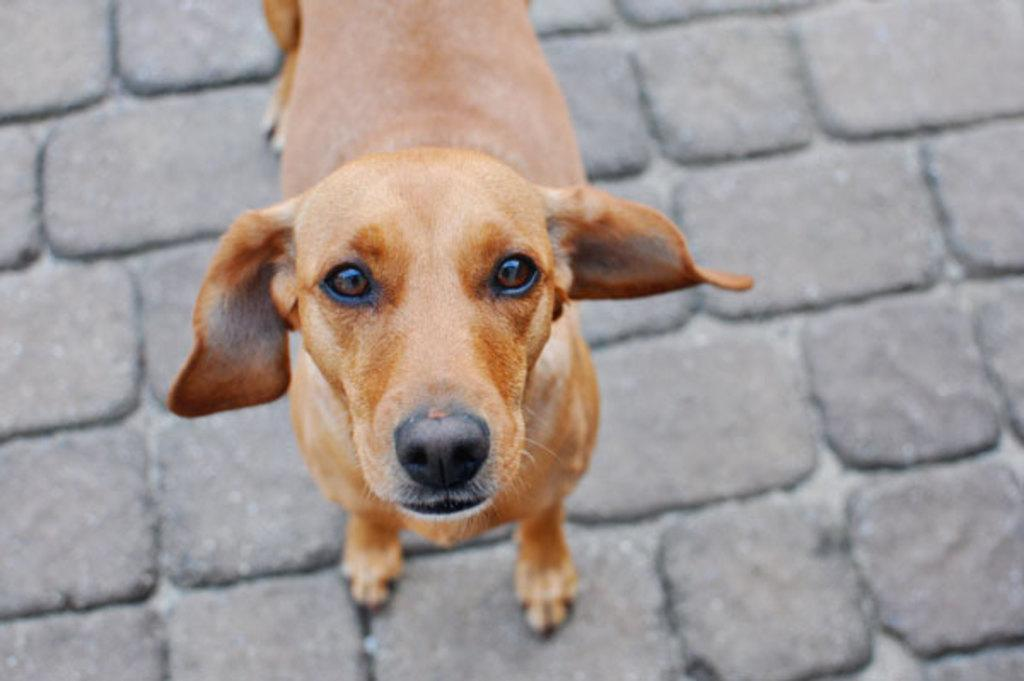What animal is present in the image? There is a dog in the image. Where is the dog positioned in the image? The dog is in the front position. How many legs of the dog are visible in the image? The dog has two legs visible in the image. What surface is the dog on in the image? The dog is on the ground. What type of laborer is working in the background of the image? There is no laborer present in the image; it only features a dog. What dish is being served for dinner in the image? There is no dinner or dish present in the image; it only features a dog. 